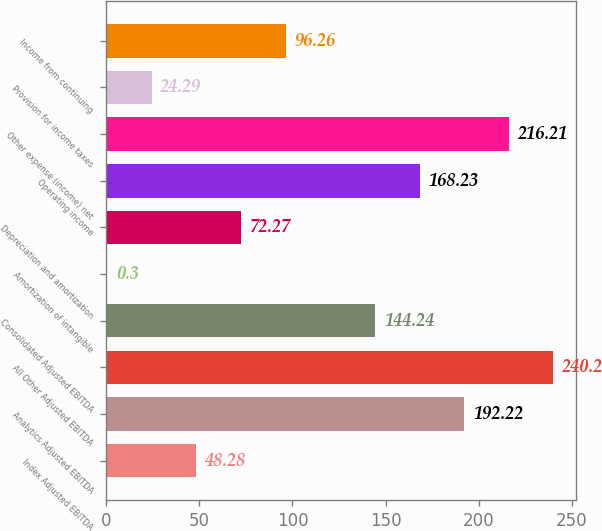Convert chart. <chart><loc_0><loc_0><loc_500><loc_500><bar_chart><fcel>Index Adjusted EBITDA<fcel>Analytics Adjusted EBITDA<fcel>All Other Adjusted EBITDA<fcel>Consolidated Adjusted EBITDA<fcel>Amortization of intangible<fcel>Depreciation and amortization<fcel>Operating income<fcel>Other expense (income) net<fcel>Provision for income taxes<fcel>Income from continuing<nl><fcel>48.28<fcel>192.22<fcel>240.2<fcel>144.24<fcel>0.3<fcel>72.27<fcel>168.23<fcel>216.21<fcel>24.29<fcel>96.26<nl></chart> 